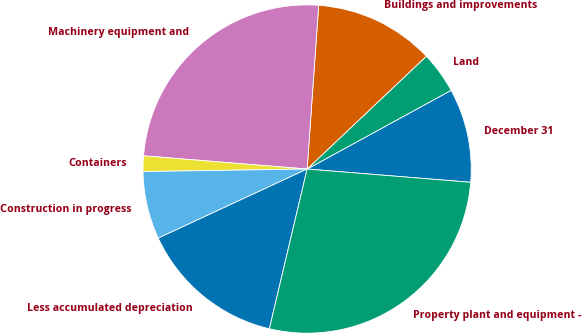Convert chart. <chart><loc_0><loc_0><loc_500><loc_500><pie_chart><fcel>December 31<fcel>Land<fcel>Buildings and improvements<fcel>Machinery equipment and<fcel>Containers<fcel>Construction in progress<fcel>Less accumulated depreciation<fcel>Property plant and equipment -<nl><fcel>9.25%<fcel>4.1%<fcel>11.82%<fcel>24.84%<fcel>1.53%<fcel>6.67%<fcel>14.39%<fcel>27.41%<nl></chart> 